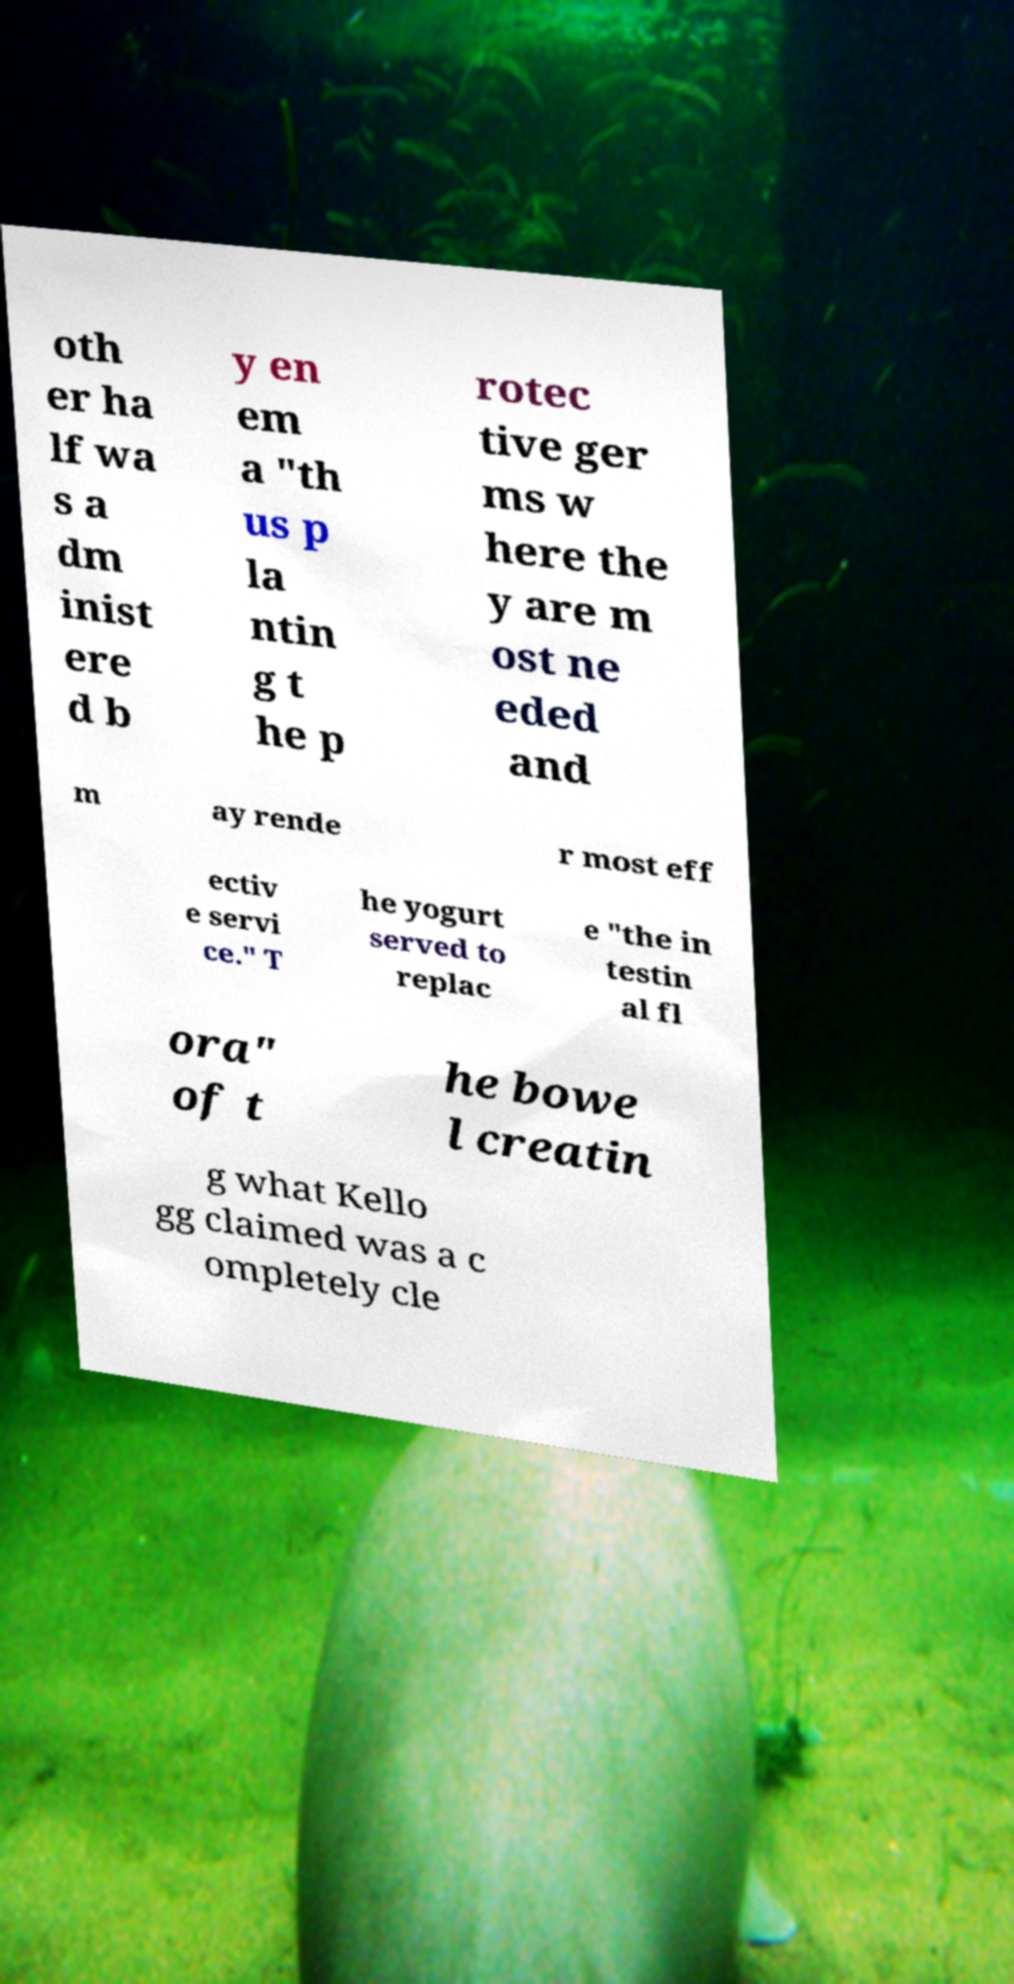There's text embedded in this image that I need extracted. Can you transcribe it verbatim? oth er ha lf wa s a dm inist ere d b y en em a "th us p la ntin g t he p rotec tive ger ms w here the y are m ost ne eded and m ay rende r most eff ectiv e servi ce." T he yogurt served to replac e "the in testin al fl ora" of t he bowe l creatin g what Kello gg claimed was a c ompletely cle 